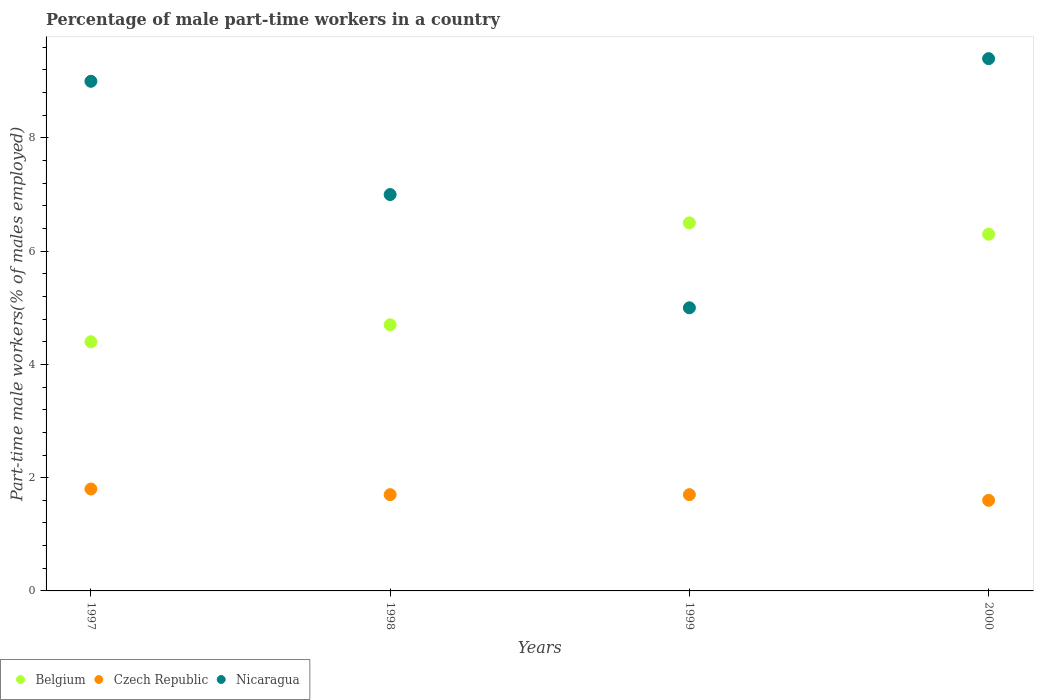Is the number of dotlines equal to the number of legend labels?
Keep it short and to the point. Yes. What is the percentage of male part-time workers in Czech Republic in 1999?
Provide a short and direct response. 1.7. Across all years, what is the maximum percentage of male part-time workers in Belgium?
Your response must be concise. 6.5. Across all years, what is the minimum percentage of male part-time workers in Nicaragua?
Offer a terse response. 5. In which year was the percentage of male part-time workers in Czech Republic maximum?
Give a very brief answer. 1997. In which year was the percentage of male part-time workers in Belgium minimum?
Your answer should be very brief. 1997. What is the total percentage of male part-time workers in Czech Republic in the graph?
Offer a very short reply. 6.8. What is the difference between the percentage of male part-time workers in Czech Republic in 1999 and that in 2000?
Provide a succinct answer. 0.1. What is the difference between the percentage of male part-time workers in Czech Republic in 1998 and the percentage of male part-time workers in Belgium in 1999?
Your answer should be compact. -4.8. What is the average percentage of male part-time workers in Belgium per year?
Offer a very short reply. 5.48. In the year 1998, what is the difference between the percentage of male part-time workers in Nicaragua and percentage of male part-time workers in Belgium?
Provide a short and direct response. 2.3. In how many years, is the percentage of male part-time workers in Czech Republic greater than 2 %?
Give a very brief answer. 0. What is the ratio of the percentage of male part-time workers in Belgium in 1999 to that in 2000?
Keep it short and to the point. 1.03. Is the percentage of male part-time workers in Czech Republic in 1998 less than that in 2000?
Provide a succinct answer. No. Is the difference between the percentage of male part-time workers in Nicaragua in 1998 and 2000 greater than the difference between the percentage of male part-time workers in Belgium in 1998 and 2000?
Your response must be concise. No. What is the difference between the highest and the second highest percentage of male part-time workers in Czech Republic?
Offer a very short reply. 0.1. What is the difference between the highest and the lowest percentage of male part-time workers in Belgium?
Provide a succinct answer. 2.1. In how many years, is the percentage of male part-time workers in Belgium greater than the average percentage of male part-time workers in Belgium taken over all years?
Provide a short and direct response. 2. Is the sum of the percentage of male part-time workers in Czech Republic in 1997 and 2000 greater than the maximum percentage of male part-time workers in Nicaragua across all years?
Ensure brevity in your answer.  No. Where does the legend appear in the graph?
Offer a terse response. Bottom left. How many legend labels are there?
Provide a succinct answer. 3. How are the legend labels stacked?
Give a very brief answer. Horizontal. What is the title of the graph?
Provide a short and direct response. Percentage of male part-time workers in a country. Does "Aruba" appear as one of the legend labels in the graph?
Keep it short and to the point. No. What is the label or title of the Y-axis?
Offer a very short reply. Part-time male workers(% of males employed). What is the Part-time male workers(% of males employed) in Belgium in 1997?
Give a very brief answer. 4.4. What is the Part-time male workers(% of males employed) in Czech Republic in 1997?
Provide a short and direct response. 1.8. What is the Part-time male workers(% of males employed) of Nicaragua in 1997?
Offer a terse response. 9. What is the Part-time male workers(% of males employed) in Belgium in 1998?
Your answer should be compact. 4.7. What is the Part-time male workers(% of males employed) in Czech Republic in 1998?
Provide a short and direct response. 1.7. What is the Part-time male workers(% of males employed) of Belgium in 1999?
Keep it short and to the point. 6.5. What is the Part-time male workers(% of males employed) in Czech Republic in 1999?
Offer a very short reply. 1.7. What is the Part-time male workers(% of males employed) in Nicaragua in 1999?
Give a very brief answer. 5. What is the Part-time male workers(% of males employed) of Belgium in 2000?
Your answer should be compact. 6.3. What is the Part-time male workers(% of males employed) in Czech Republic in 2000?
Your response must be concise. 1.6. What is the Part-time male workers(% of males employed) of Nicaragua in 2000?
Your response must be concise. 9.4. Across all years, what is the maximum Part-time male workers(% of males employed) of Czech Republic?
Ensure brevity in your answer.  1.8. Across all years, what is the maximum Part-time male workers(% of males employed) of Nicaragua?
Keep it short and to the point. 9.4. Across all years, what is the minimum Part-time male workers(% of males employed) in Belgium?
Your response must be concise. 4.4. Across all years, what is the minimum Part-time male workers(% of males employed) of Czech Republic?
Your answer should be very brief. 1.6. Across all years, what is the minimum Part-time male workers(% of males employed) in Nicaragua?
Make the answer very short. 5. What is the total Part-time male workers(% of males employed) in Belgium in the graph?
Your answer should be compact. 21.9. What is the total Part-time male workers(% of males employed) in Czech Republic in the graph?
Your response must be concise. 6.8. What is the total Part-time male workers(% of males employed) in Nicaragua in the graph?
Your answer should be compact. 30.4. What is the difference between the Part-time male workers(% of males employed) in Belgium in 1997 and that in 1998?
Your answer should be very brief. -0.3. What is the difference between the Part-time male workers(% of males employed) in Czech Republic in 1997 and that in 1998?
Provide a short and direct response. 0.1. What is the difference between the Part-time male workers(% of males employed) of Belgium in 1997 and that in 1999?
Ensure brevity in your answer.  -2.1. What is the difference between the Part-time male workers(% of males employed) in Czech Republic in 1997 and that in 1999?
Provide a succinct answer. 0.1. What is the difference between the Part-time male workers(% of males employed) of Nicaragua in 1997 and that in 1999?
Your answer should be very brief. 4. What is the difference between the Part-time male workers(% of males employed) in Belgium in 1997 and that in 2000?
Provide a short and direct response. -1.9. What is the difference between the Part-time male workers(% of males employed) of Czech Republic in 1998 and that in 1999?
Make the answer very short. 0. What is the difference between the Part-time male workers(% of males employed) of Nicaragua in 1998 and that in 1999?
Keep it short and to the point. 2. What is the difference between the Part-time male workers(% of males employed) in Nicaragua in 1998 and that in 2000?
Provide a succinct answer. -2.4. What is the difference between the Part-time male workers(% of males employed) in Belgium in 1999 and that in 2000?
Offer a terse response. 0.2. What is the difference between the Part-time male workers(% of males employed) of Czech Republic in 1999 and that in 2000?
Keep it short and to the point. 0.1. What is the difference between the Part-time male workers(% of males employed) in Belgium in 1997 and the Part-time male workers(% of males employed) in Czech Republic in 1998?
Your answer should be very brief. 2.7. What is the difference between the Part-time male workers(% of males employed) of Czech Republic in 1997 and the Part-time male workers(% of males employed) of Nicaragua in 1998?
Keep it short and to the point. -5.2. What is the difference between the Part-time male workers(% of males employed) of Belgium in 1997 and the Part-time male workers(% of males employed) of Nicaragua in 1999?
Your answer should be compact. -0.6. What is the difference between the Part-time male workers(% of males employed) of Belgium in 1997 and the Part-time male workers(% of males employed) of Czech Republic in 2000?
Make the answer very short. 2.8. What is the difference between the Part-time male workers(% of males employed) in Belgium in 1997 and the Part-time male workers(% of males employed) in Nicaragua in 2000?
Offer a very short reply. -5. What is the difference between the Part-time male workers(% of males employed) in Belgium in 1998 and the Part-time male workers(% of males employed) in Nicaragua in 1999?
Provide a succinct answer. -0.3. What is the difference between the Part-time male workers(% of males employed) in Czech Republic in 1998 and the Part-time male workers(% of males employed) in Nicaragua in 1999?
Your answer should be very brief. -3.3. What is the difference between the Part-time male workers(% of males employed) in Belgium in 1998 and the Part-time male workers(% of males employed) in Czech Republic in 2000?
Provide a succinct answer. 3.1. What is the difference between the Part-time male workers(% of males employed) in Belgium in 1998 and the Part-time male workers(% of males employed) in Nicaragua in 2000?
Provide a succinct answer. -4.7. What is the difference between the Part-time male workers(% of males employed) in Czech Republic in 1998 and the Part-time male workers(% of males employed) in Nicaragua in 2000?
Offer a terse response. -7.7. What is the difference between the Part-time male workers(% of males employed) of Czech Republic in 1999 and the Part-time male workers(% of males employed) of Nicaragua in 2000?
Your answer should be very brief. -7.7. What is the average Part-time male workers(% of males employed) of Belgium per year?
Provide a short and direct response. 5.47. In the year 1997, what is the difference between the Part-time male workers(% of males employed) of Belgium and Part-time male workers(% of males employed) of Czech Republic?
Offer a very short reply. 2.6. In the year 1997, what is the difference between the Part-time male workers(% of males employed) of Belgium and Part-time male workers(% of males employed) of Nicaragua?
Provide a short and direct response. -4.6. In the year 1998, what is the difference between the Part-time male workers(% of males employed) of Belgium and Part-time male workers(% of males employed) of Nicaragua?
Ensure brevity in your answer.  -2.3. In the year 1998, what is the difference between the Part-time male workers(% of males employed) of Czech Republic and Part-time male workers(% of males employed) of Nicaragua?
Your response must be concise. -5.3. In the year 1999, what is the difference between the Part-time male workers(% of males employed) of Belgium and Part-time male workers(% of males employed) of Nicaragua?
Ensure brevity in your answer.  1.5. In the year 1999, what is the difference between the Part-time male workers(% of males employed) of Czech Republic and Part-time male workers(% of males employed) of Nicaragua?
Keep it short and to the point. -3.3. In the year 2000, what is the difference between the Part-time male workers(% of males employed) in Belgium and Part-time male workers(% of males employed) in Czech Republic?
Keep it short and to the point. 4.7. In the year 2000, what is the difference between the Part-time male workers(% of males employed) in Czech Republic and Part-time male workers(% of males employed) in Nicaragua?
Make the answer very short. -7.8. What is the ratio of the Part-time male workers(% of males employed) in Belgium in 1997 to that in 1998?
Make the answer very short. 0.94. What is the ratio of the Part-time male workers(% of males employed) of Czech Republic in 1997 to that in 1998?
Offer a very short reply. 1.06. What is the ratio of the Part-time male workers(% of males employed) in Belgium in 1997 to that in 1999?
Offer a terse response. 0.68. What is the ratio of the Part-time male workers(% of males employed) of Czech Republic in 1997 to that in 1999?
Your answer should be compact. 1.06. What is the ratio of the Part-time male workers(% of males employed) of Nicaragua in 1997 to that in 1999?
Offer a very short reply. 1.8. What is the ratio of the Part-time male workers(% of males employed) of Belgium in 1997 to that in 2000?
Your answer should be very brief. 0.7. What is the ratio of the Part-time male workers(% of males employed) of Czech Republic in 1997 to that in 2000?
Ensure brevity in your answer.  1.12. What is the ratio of the Part-time male workers(% of males employed) of Nicaragua in 1997 to that in 2000?
Keep it short and to the point. 0.96. What is the ratio of the Part-time male workers(% of males employed) of Belgium in 1998 to that in 1999?
Provide a short and direct response. 0.72. What is the ratio of the Part-time male workers(% of males employed) of Nicaragua in 1998 to that in 1999?
Your answer should be compact. 1.4. What is the ratio of the Part-time male workers(% of males employed) of Belgium in 1998 to that in 2000?
Give a very brief answer. 0.75. What is the ratio of the Part-time male workers(% of males employed) in Nicaragua in 1998 to that in 2000?
Make the answer very short. 0.74. What is the ratio of the Part-time male workers(% of males employed) in Belgium in 1999 to that in 2000?
Offer a terse response. 1.03. What is the ratio of the Part-time male workers(% of males employed) in Nicaragua in 1999 to that in 2000?
Your response must be concise. 0.53. What is the difference between the highest and the second highest Part-time male workers(% of males employed) of Belgium?
Make the answer very short. 0.2. What is the difference between the highest and the second highest Part-time male workers(% of males employed) in Czech Republic?
Your response must be concise. 0.1. What is the difference between the highest and the second highest Part-time male workers(% of males employed) of Nicaragua?
Your response must be concise. 0.4. What is the difference between the highest and the lowest Part-time male workers(% of males employed) in Belgium?
Ensure brevity in your answer.  2.1. What is the difference between the highest and the lowest Part-time male workers(% of males employed) of Czech Republic?
Ensure brevity in your answer.  0.2. 